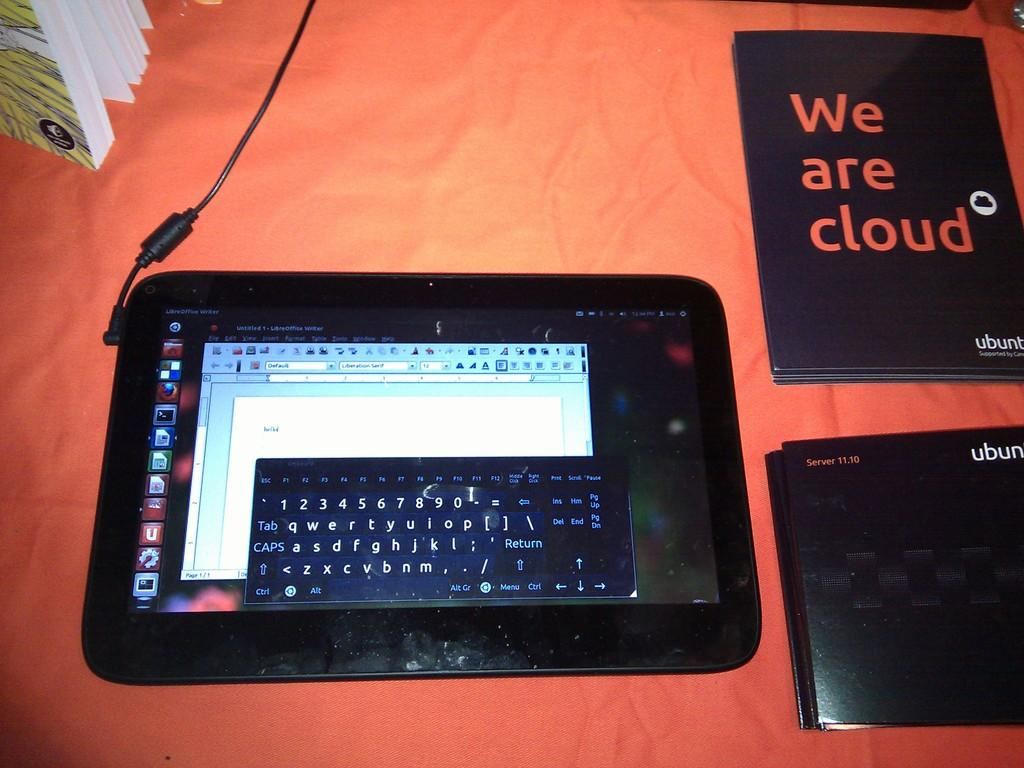What is the main object in the image? There is a tab in the image. What else can be seen in the image besides the tab? There are books in the image. What color is the background of the image? The background of the image is in orange color. What nation is represented by the tab in the image? The image does not depict a nation or any national symbols; it only shows a tab and books. 